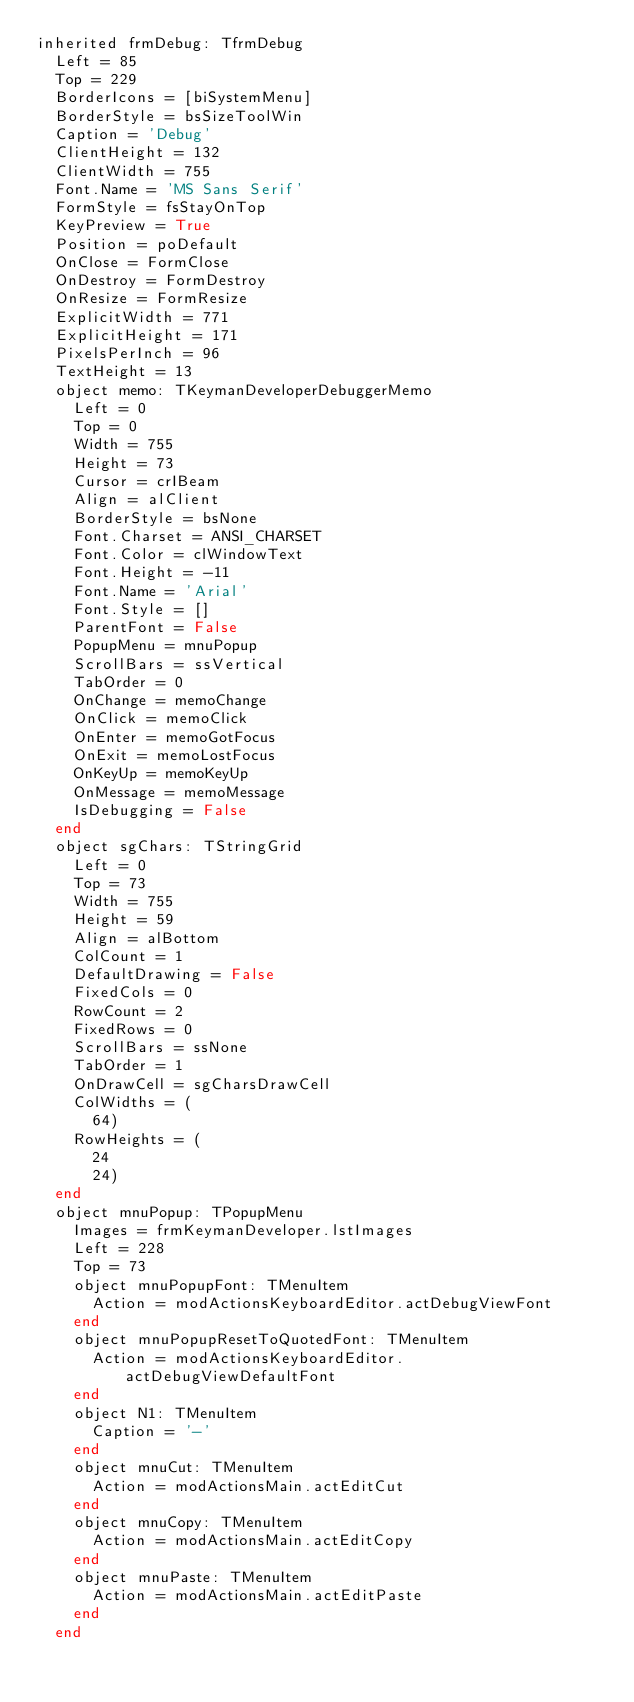Convert code to text. <code><loc_0><loc_0><loc_500><loc_500><_Pascal_>inherited frmDebug: TfrmDebug
  Left = 85
  Top = 229
  BorderIcons = [biSystemMenu]
  BorderStyle = bsSizeToolWin
  Caption = 'Debug'
  ClientHeight = 132
  ClientWidth = 755
  Font.Name = 'MS Sans Serif'
  FormStyle = fsStayOnTop
  KeyPreview = True
  Position = poDefault
  OnClose = FormClose
  OnDestroy = FormDestroy
  OnResize = FormResize
  ExplicitWidth = 771
  ExplicitHeight = 171
  PixelsPerInch = 96
  TextHeight = 13
  object memo: TKeymanDeveloperDebuggerMemo
    Left = 0
    Top = 0
    Width = 755
    Height = 73
    Cursor = crIBeam
    Align = alClient
    BorderStyle = bsNone
    Font.Charset = ANSI_CHARSET
    Font.Color = clWindowText
    Font.Height = -11
    Font.Name = 'Arial'
    Font.Style = []
    ParentFont = False
    PopupMenu = mnuPopup
    ScrollBars = ssVertical
    TabOrder = 0
    OnChange = memoChange
    OnClick = memoClick
    OnEnter = memoGotFocus
    OnExit = memoLostFocus
    OnKeyUp = memoKeyUp
    OnMessage = memoMessage
    IsDebugging = False
  end
  object sgChars: TStringGrid
    Left = 0
    Top = 73
    Width = 755
    Height = 59
    Align = alBottom
    ColCount = 1
    DefaultDrawing = False
    FixedCols = 0
    RowCount = 2
    FixedRows = 0
    ScrollBars = ssNone
    TabOrder = 1
    OnDrawCell = sgCharsDrawCell
    ColWidths = (
      64)
    RowHeights = (
      24
      24)
  end
  object mnuPopup: TPopupMenu
    Images = frmKeymanDeveloper.lstImages
    Left = 228
    Top = 73
    object mnuPopupFont: TMenuItem
      Action = modActionsKeyboardEditor.actDebugViewFont
    end
    object mnuPopupResetToQuotedFont: TMenuItem
      Action = modActionsKeyboardEditor.actDebugViewDefaultFont
    end
    object N1: TMenuItem
      Caption = '-'
    end
    object mnuCut: TMenuItem
      Action = modActionsMain.actEditCut
    end
    object mnuCopy: TMenuItem
      Action = modActionsMain.actEditCopy
    end
    object mnuPaste: TMenuItem
      Action = modActionsMain.actEditPaste
    end
  end</code> 